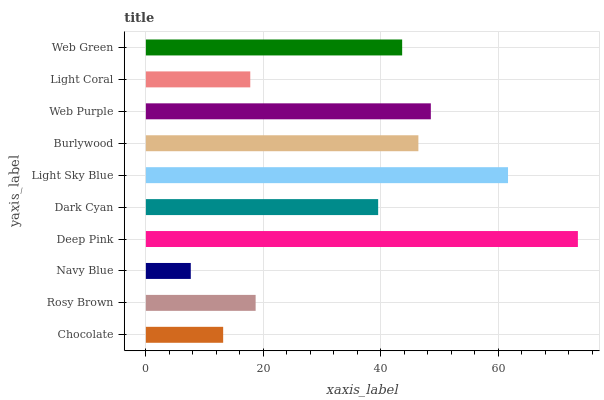Is Navy Blue the minimum?
Answer yes or no. Yes. Is Deep Pink the maximum?
Answer yes or no. Yes. Is Rosy Brown the minimum?
Answer yes or no. No. Is Rosy Brown the maximum?
Answer yes or no. No. Is Rosy Brown greater than Chocolate?
Answer yes or no. Yes. Is Chocolate less than Rosy Brown?
Answer yes or no. Yes. Is Chocolate greater than Rosy Brown?
Answer yes or no. No. Is Rosy Brown less than Chocolate?
Answer yes or no. No. Is Web Green the high median?
Answer yes or no. Yes. Is Dark Cyan the low median?
Answer yes or no. Yes. Is Dark Cyan the high median?
Answer yes or no. No. Is Web Green the low median?
Answer yes or no. No. 